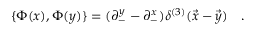Convert formula to latex. <formula><loc_0><loc_0><loc_500><loc_500>\{ \Phi ( x ) , \Phi ( y ) \} = ( \partial _ { - } ^ { y } - \partial _ { - } ^ { x } ) \delta ^ { ( 3 ) } ( \vec { x } - \vec { y } ) \quad .</formula> 